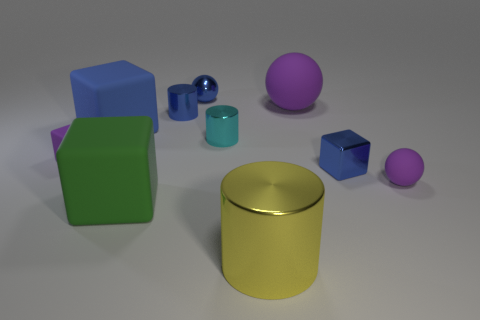There is a shiny block; is it the same color as the block in front of the metal block?
Ensure brevity in your answer.  No. There is a blue block that is in front of the big block behind the matte thing that is to the right of the large rubber ball; how big is it?
Offer a terse response. Small. How many large matte things are the same color as the big rubber sphere?
Provide a short and direct response. 0. What number of objects are either tiny purple matte cubes or large rubber cubes to the left of the cyan shiny object?
Give a very brief answer. 3. What is the color of the metallic sphere?
Your answer should be very brief. Blue. What is the color of the shiny cylinder that is behind the blue matte block?
Your answer should be compact. Blue. There is a block that is right of the large matte ball; what number of tiny cyan shiny things are on the left side of it?
Offer a very short reply. 1. There is a cyan metal thing; does it have the same size as the blue block that is in front of the large blue block?
Keep it short and to the point. Yes. Is there a cyan cube that has the same size as the green object?
Make the answer very short. No. What number of objects are cyan cylinders or matte cylinders?
Provide a short and direct response. 1. 